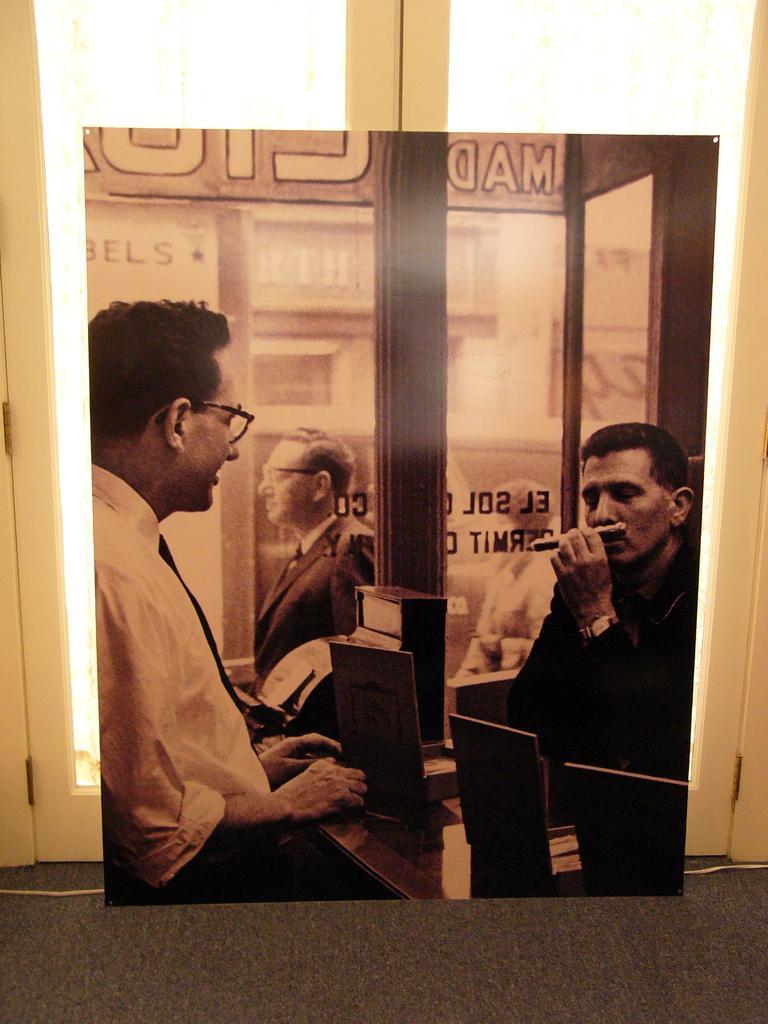Can you describe this image briefly? In this picture there is a person wearing white shirt and there is a table in front of him which has few objects placed on it and there is another person in front of him and there is a glass beside them which has something written on it and there is a person in the background. 